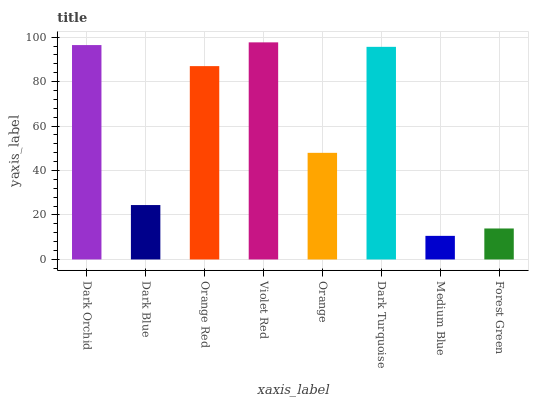Is Dark Blue the minimum?
Answer yes or no. No. Is Dark Blue the maximum?
Answer yes or no. No. Is Dark Orchid greater than Dark Blue?
Answer yes or no. Yes. Is Dark Blue less than Dark Orchid?
Answer yes or no. Yes. Is Dark Blue greater than Dark Orchid?
Answer yes or no. No. Is Dark Orchid less than Dark Blue?
Answer yes or no. No. Is Orange Red the high median?
Answer yes or no. Yes. Is Orange the low median?
Answer yes or no. Yes. Is Dark Blue the high median?
Answer yes or no. No. Is Forest Green the low median?
Answer yes or no. No. 